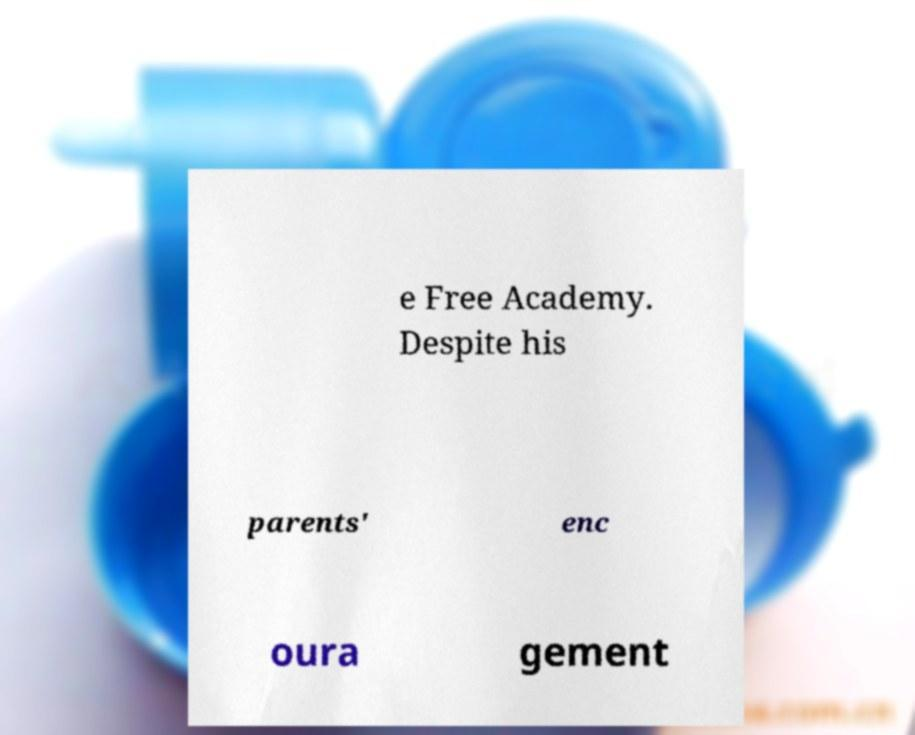I need the written content from this picture converted into text. Can you do that? e Free Academy. Despite his parents' enc oura gement 